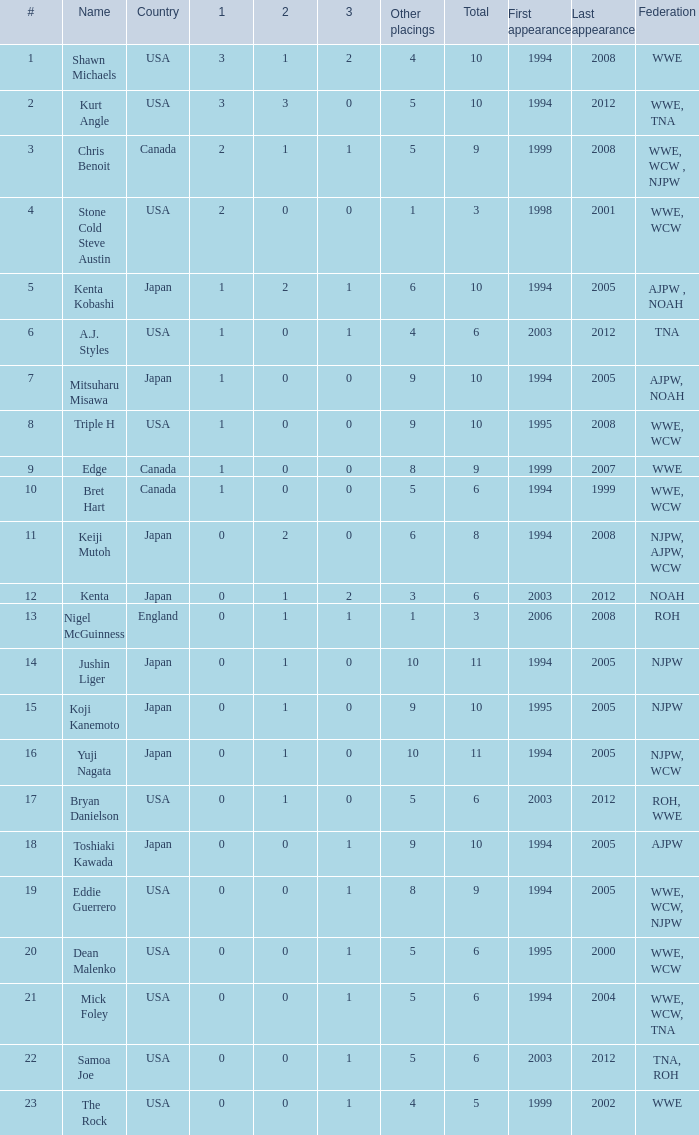What countries does the Rock come from? 1.0. 